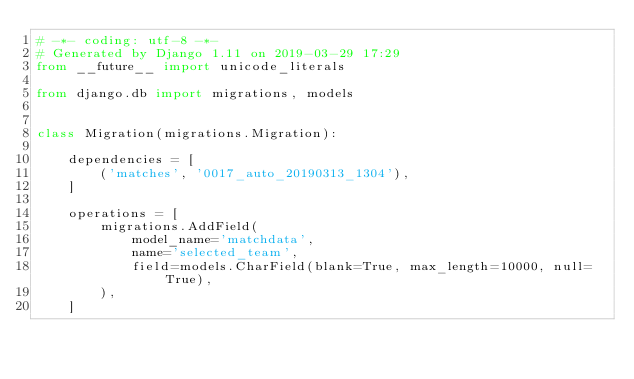Convert code to text. <code><loc_0><loc_0><loc_500><loc_500><_Python_># -*- coding: utf-8 -*-
# Generated by Django 1.11 on 2019-03-29 17:29
from __future__ import unicode_literals

from django.db import migrations, models


class Migration(migrations.Migration):

    dependencies = [
        ('matches', '0017_auto_20190313_1304'),
    ]

    operations = [
        migrations.AddField(
            model_name='matchdata',
            name='selected_team',
            field=models.CharField(blank=True, max_length=10000, null=True),
        ),
    ]
</code> 